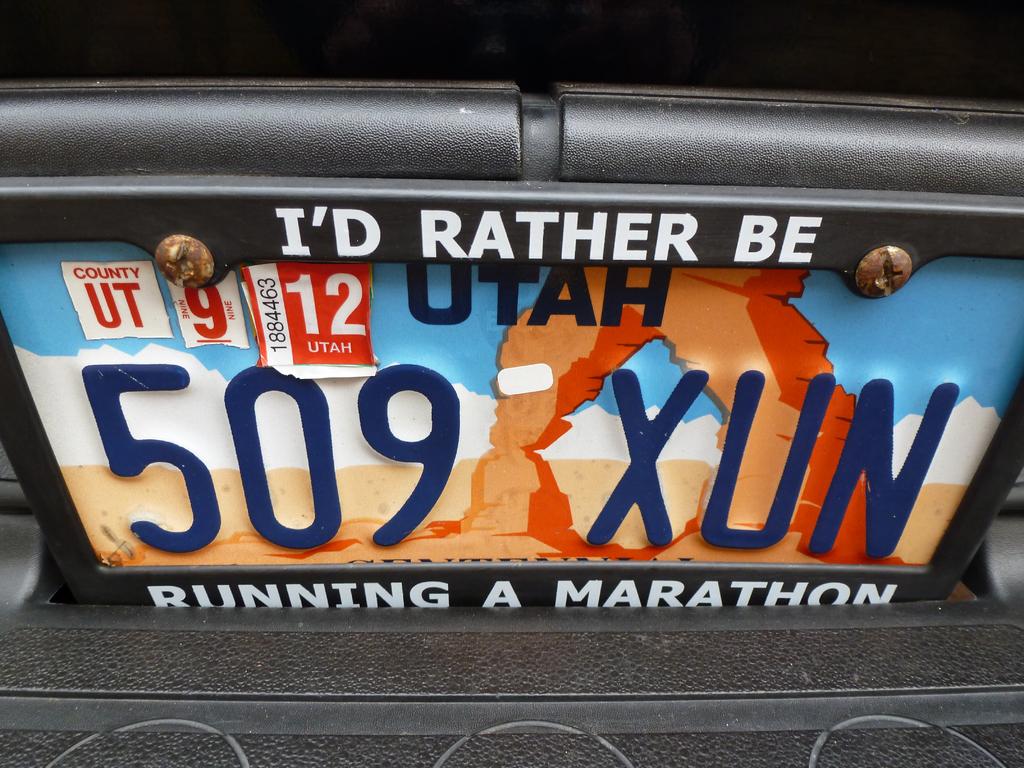Where would this car owner rather be?
Ensure brevity in your answer.  Running a marathon. Which state in the runner from?
Ensure brevity in your answer.  Utah. 